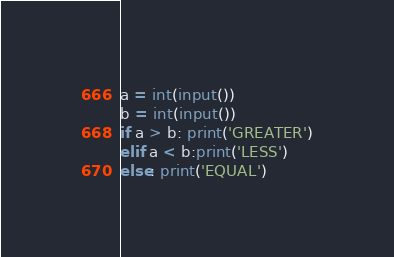Convert code to text. <code><loc_0><loc_0><loc_500><loc_500><_Python_>a = int(input())
b = int(input())
if a > b: print('GREATER')
elif a < b:print('LESS')
else: print('EQUAL')
</code> 